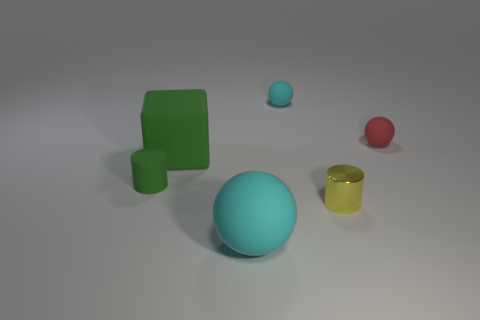Add 4 tiny green matte cylinders. How many objects exist? 10 Subtract all cubes. How many objects are left? 5 Add 2 tiny yellow cylinders. How many tiny yellow cylinders are left? 3 Add 4 small cylinders. How many small cylinders exist? 6 Subtract 1 yellow cylinders. How many objects are left? 5 Subtract all small things. Subtract all big red rubber things. How many objects are left? 2 